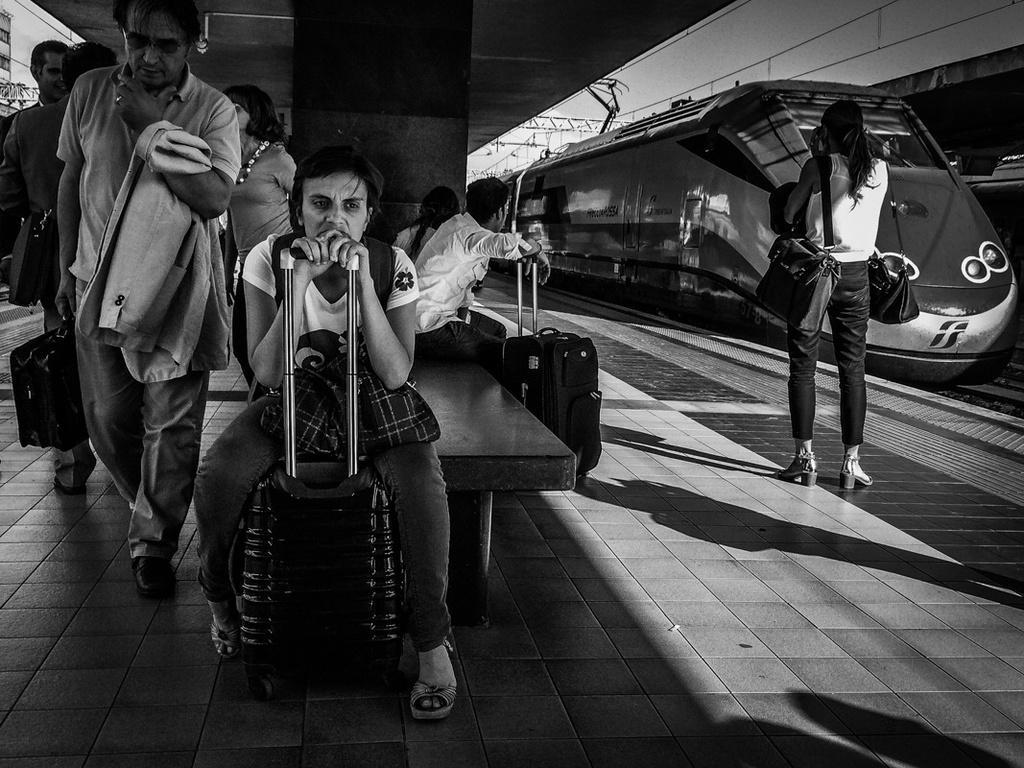How would you summarize this image in a sentence or two? Black and white picture. Train is on the track. Here we can see people. These people are sitting and holding their luggage. This woman wore bags. 